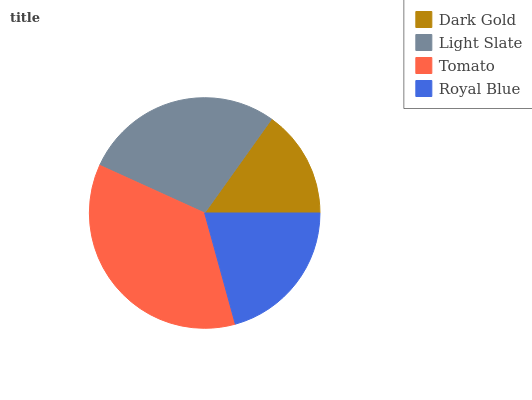Is Dark Gold the minimum?
Answer yes or no. Yes. Is Tomato the maximum?
Answer yes or no. Yes. Is Light Slate the minimum?
Answer yes or no. No. Is Light Slate the maximum?
Answer yes or no. No. Is Light Slate greater than Dark Gold?
Answer yes or no. Yes. Is Dark Gold less than Light Slate?
Answer yes or no. Yes. Is Dark Gold greater than Light Slate?
Answer yes or no. No. Is Light Slate less than Dark Gold?
Answer yes or no. No. Is Light Slate the high median?
Answer yes or no. Yes. Is Royal Blue the low median?
Answer yes or no. Yes. Is Dark Gold the high median?
Answer yes or no. No. Is Light Slate the low median?
Answer yes or no. No. 